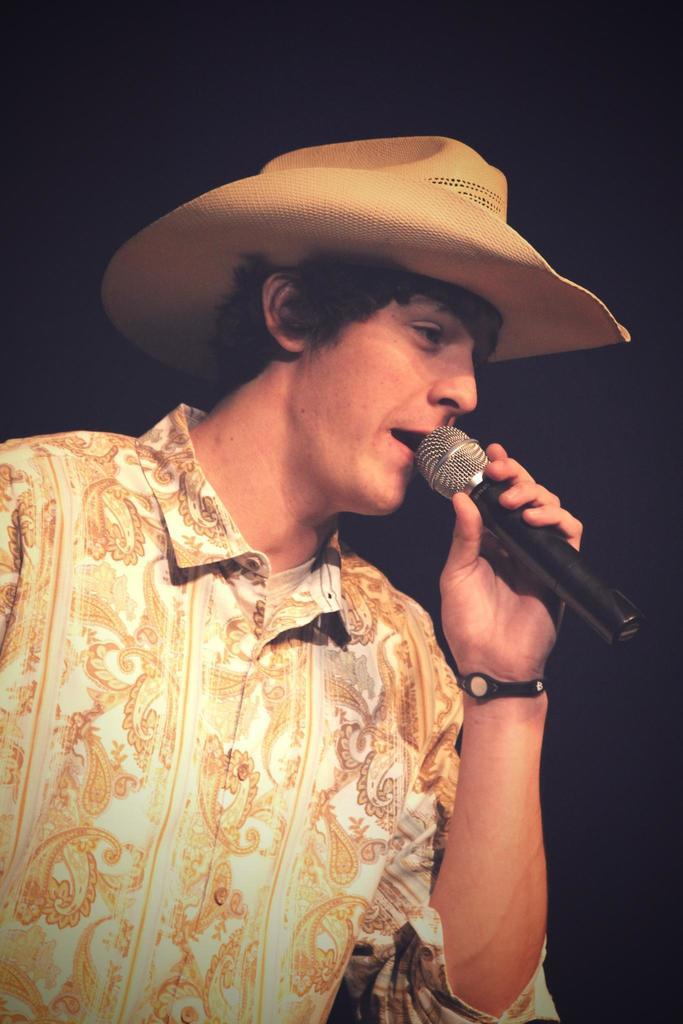Who is the main subject in the image? There is a man in the image. What is the man wearing? The man is wearing a floral shirt and a hat. What object is the man holding? The man is holding a microphone. What is the color of the background in the image? The background of the image is black. How does the man use the bike in the image? There is no bike present in the image, so the man cannot use a bike. What word is the man trying to spell with his hat in the image? There is no indication that the man is trying to spell a word with his hat in the image. 